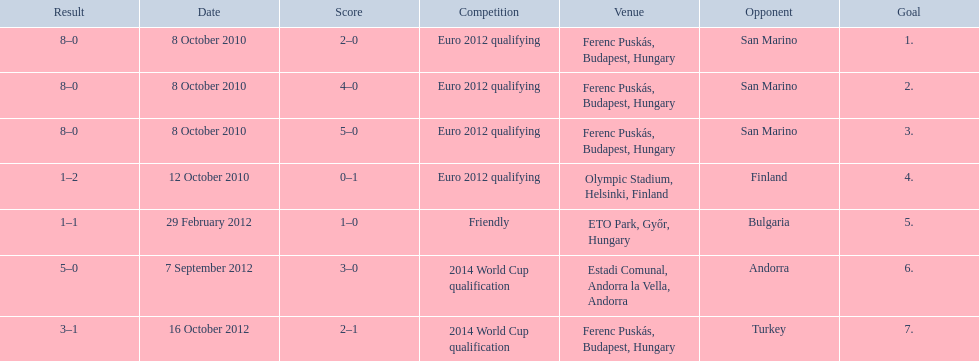How many non-qualifying games did he score in? 1. 